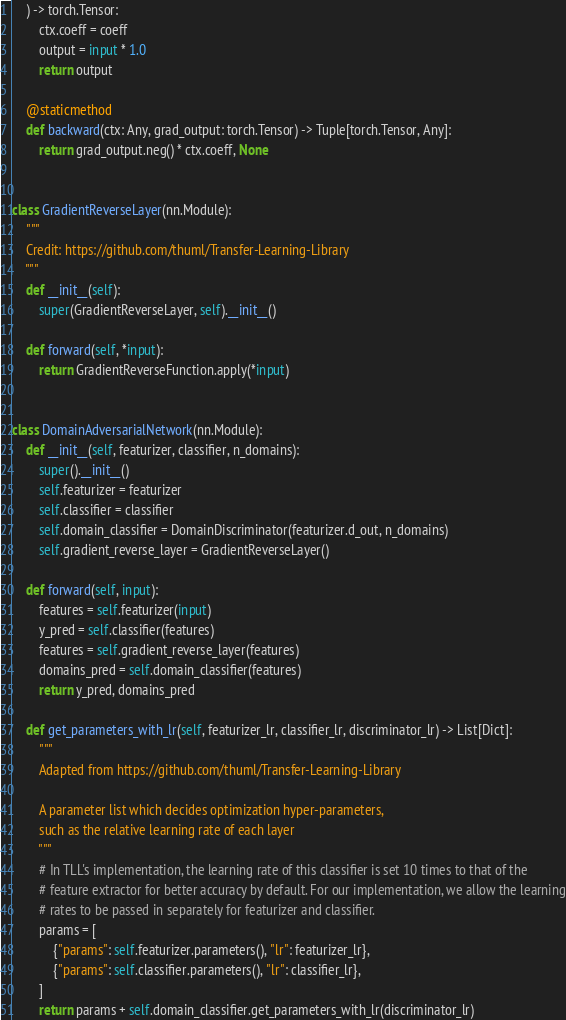<code> <loc_0><loc_0><loc_500><loc_500><_Python_>    ) -> torch.Tensor:
        ctx.coeff = coeff
        output = input * 1.0
        return output

    @staticmethod
    def backward(ctx: Any, grad_output: torch.Tensor) -> Tuple[torch.Tensor, Any]:
        return grad_output.neg() * ctx.coeff, None


class GradientReverseLayer(nn.Module):
    """
    Credit: https://github.com/thuml/Transfer-Learning-Library
    """
    def __init__(self):
        super(GradientReverseLayer, self).__init__()

    def forward(self, *input):
        return GradientReverseFunction.apply(*input)


class DomainAdversarialNetwork(nn.Module):
    def __init__(self, featurizer, classifier, n_domains):
        super().__init__()
        self.featurizer = featurizer
        self.classifier = classifier
        self.domain_classifier = DomainDiscriminator(featurizer.d_out, n_domains)
        self.gradient_reverse_layer = GradientReverseLayer()

    def forward(self, input):
        features = self.featurizer(input)
        y_pred = self.classifier(features)
        features = self.gradient_reverse_layer(features)
        domains_pred = self.domain_classifier(features)
        return y_pred, domains_pred

    def get_parameters_with_lr(self, featurizer_lr, classifier_lr, discriminator_lr) -> List[Dict]:
        """
        Adapted from https://github.com/thuml/Transfer-Learning-Library

        A parameter list which decides optimization hyper-parameters,
        such as the relative learning rate of each layer
        """
        # In TLL's implementation, the learning rate of this classifier is set 10 times to that of the
        # feature extractor for better accuracy by default. For our implementation, we allow the learning
        # rates to be passed in separately for featurizer and classifier.
        params = [
            {"params": self.featurizer.parameters(), "lr": featurizer_lr},
            {"params": self.classifier.parameters(), "lr": classifier_lr},
        ]
        return params + self.domain_classifier.get_parameters_with_lr(discriminator_lr)
</code> 